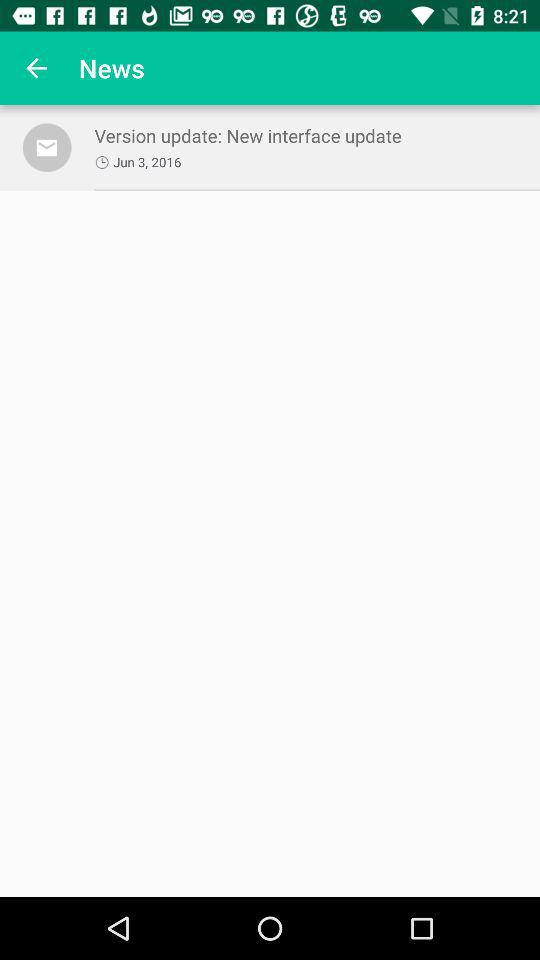What is the update date of the version? The update date of the version is June 3, 2016. 